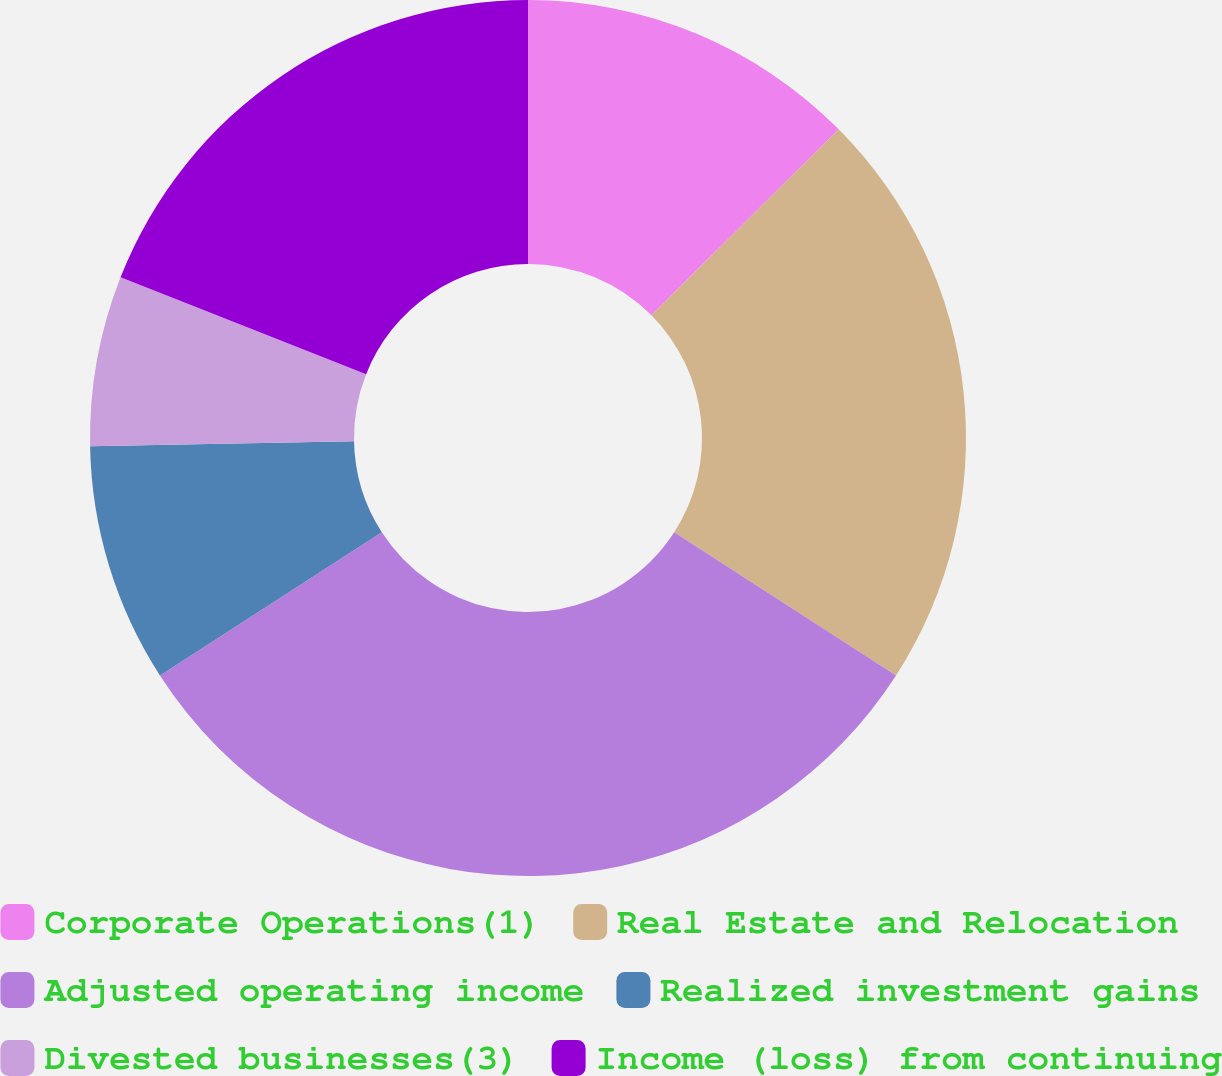Convert chart to OTSL. <chart><loc_0><loc_0><loc_500><loc_500><pie_chart><fcel>Corporate Operations(1)<fcel>Real Estate and Relocation<fcel>Adjusted operating income<fcel>Realized investment gains<fcel>Divested businesses(3)<fcel>Income (loss) from continuing<nl><fcel>12.55%<fcel>21.57%<fcel>31.76%<fcel>8.82%<fcel>6.28%<fcel>19.02%<nl></chart> 